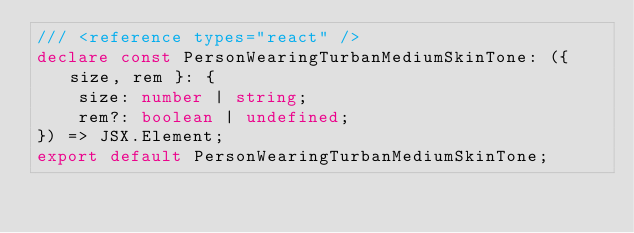Convert code to text. <code><loc_0><loc_0><loc_500><loc_500><_TypeScript_>/// <reference types="react" />
declare const PersonWearingTurbanMediumSkinTone: ({ size, rem }: {
    size: number | string;
    rem?: boolean | undefined;
}) => JSX.Element;
export default PersonWearingTurbanMediumSkinTone;
</code> 